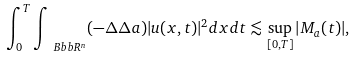<formula> <loc_0><loc_0><loc_500><loc_500>\int _ { 0 } ^ { T } \int _ { \ B b b R ^ { n } } ( - \Delta \Delta a ) | u ( x , t ) | ^ { 2 } d x d t \lesssim \sup _ { [ 0 , T ] } | M _ { a } ( t ) | ,</formula> 